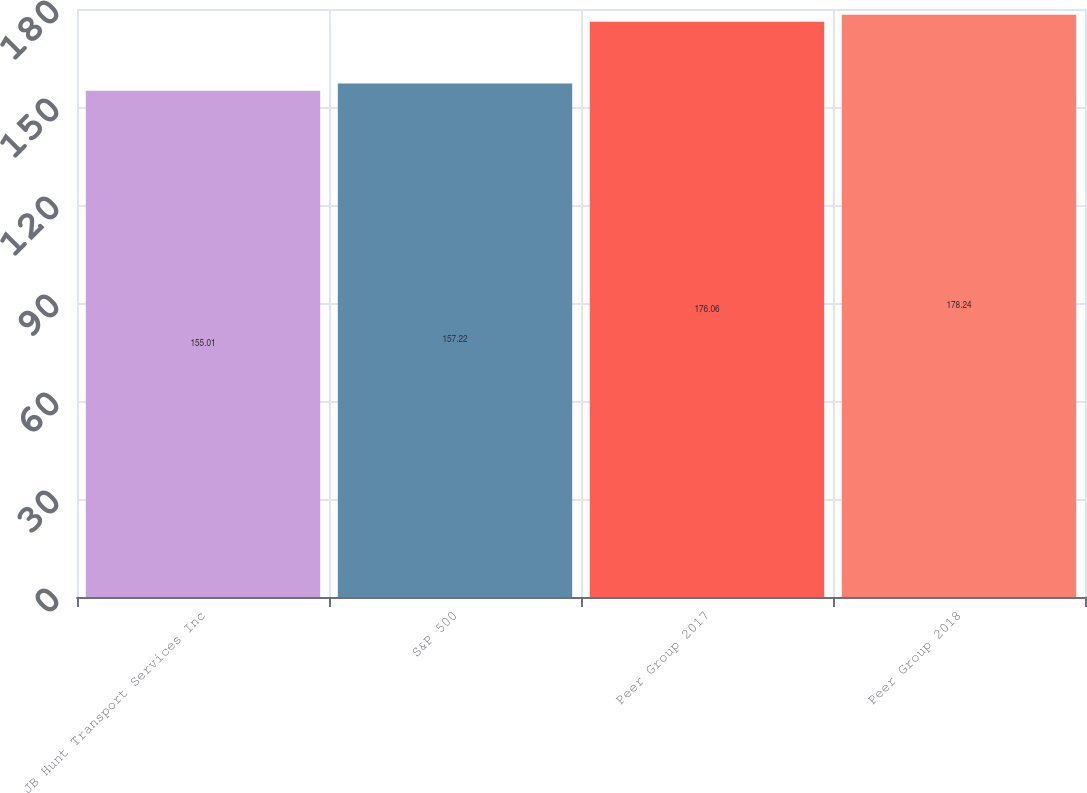Convert chart to OTSL. <chart><loc_0><loc_0><loc_500><loc_500><bar_chart><fcel>JB Hunt Transport Services Inc<fcel>S&P 500<fcel>Peer Group 2017<fcel>Peer Group 2018<nl><fcel>155.01<fcel>157.22<fcel>176.06<fcel>178.24<nl></chart> 